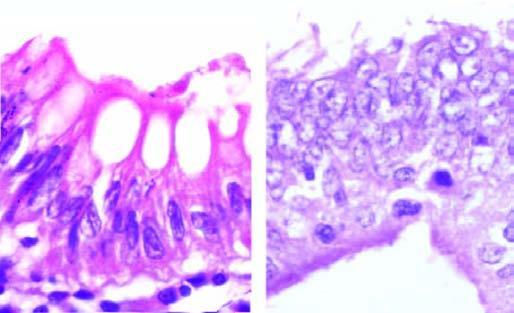s the basement membrane intact in both?
Answer the question using a single word or phrase. Yes 